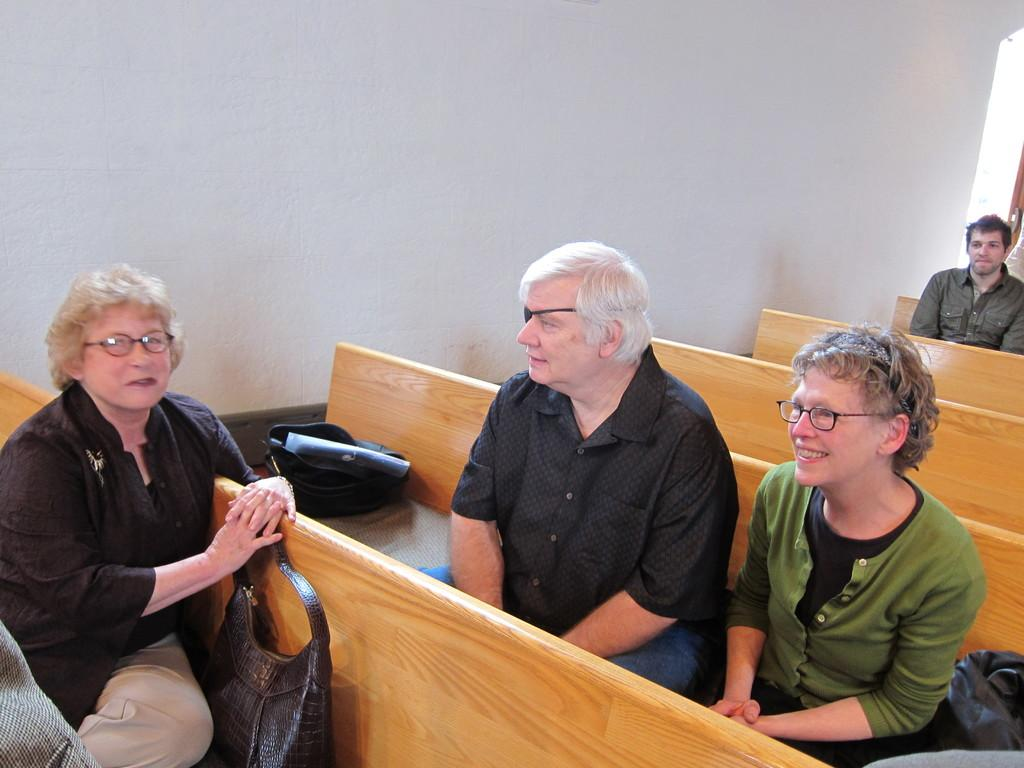What are the people in the image doing? The persons in the image are sitting on benches. What can be seen in the background of the image? There is a wall in the background of the image. How many bites of the church can be seen in the image? There is no church present in the image, and therefore no bites can be observed. 